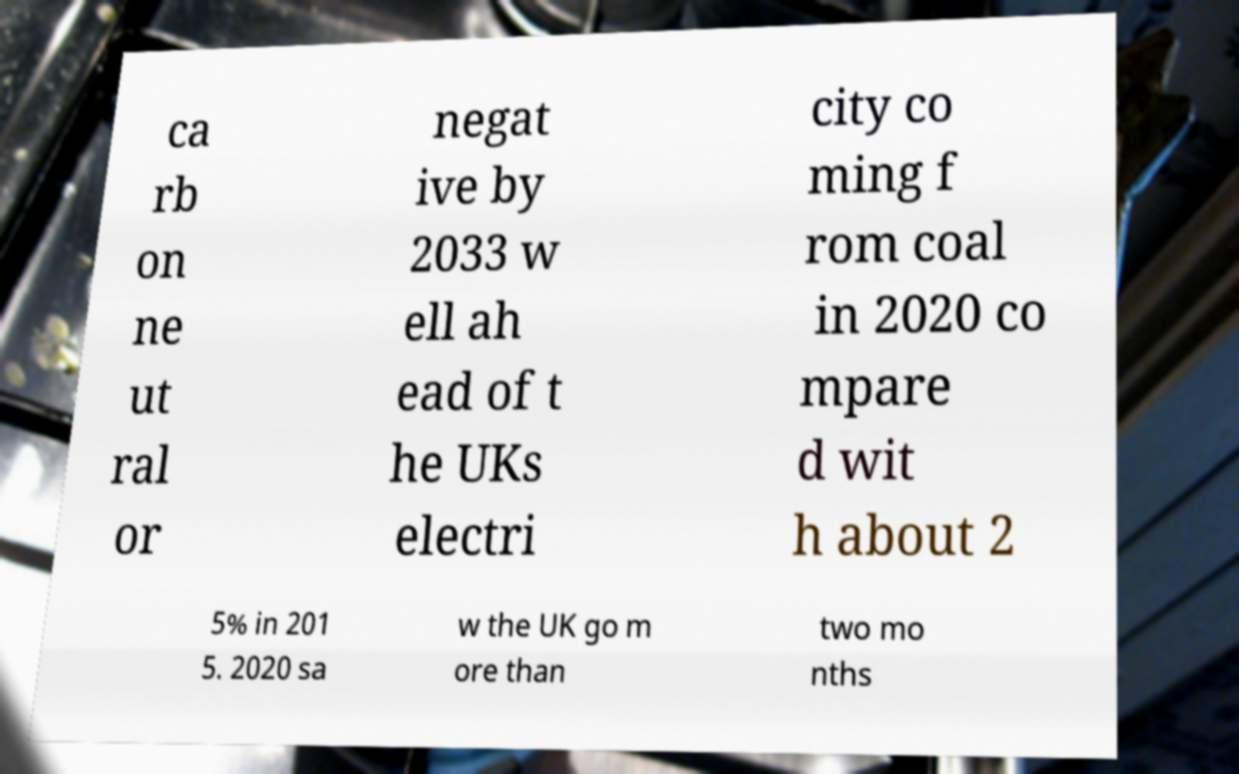Can you read and provide the text displayed in the image?This photo seems to have some interesting text. Can you extract and type it out for me? ca rb on ne ut ral or negat ive by 2033 w ell ah ead of t he UKs electri city co ming f rom coal in 2020 co mpare d wit h about 2 5% in 201 5. 2020 sa w the UK go m ore than two mo nths 